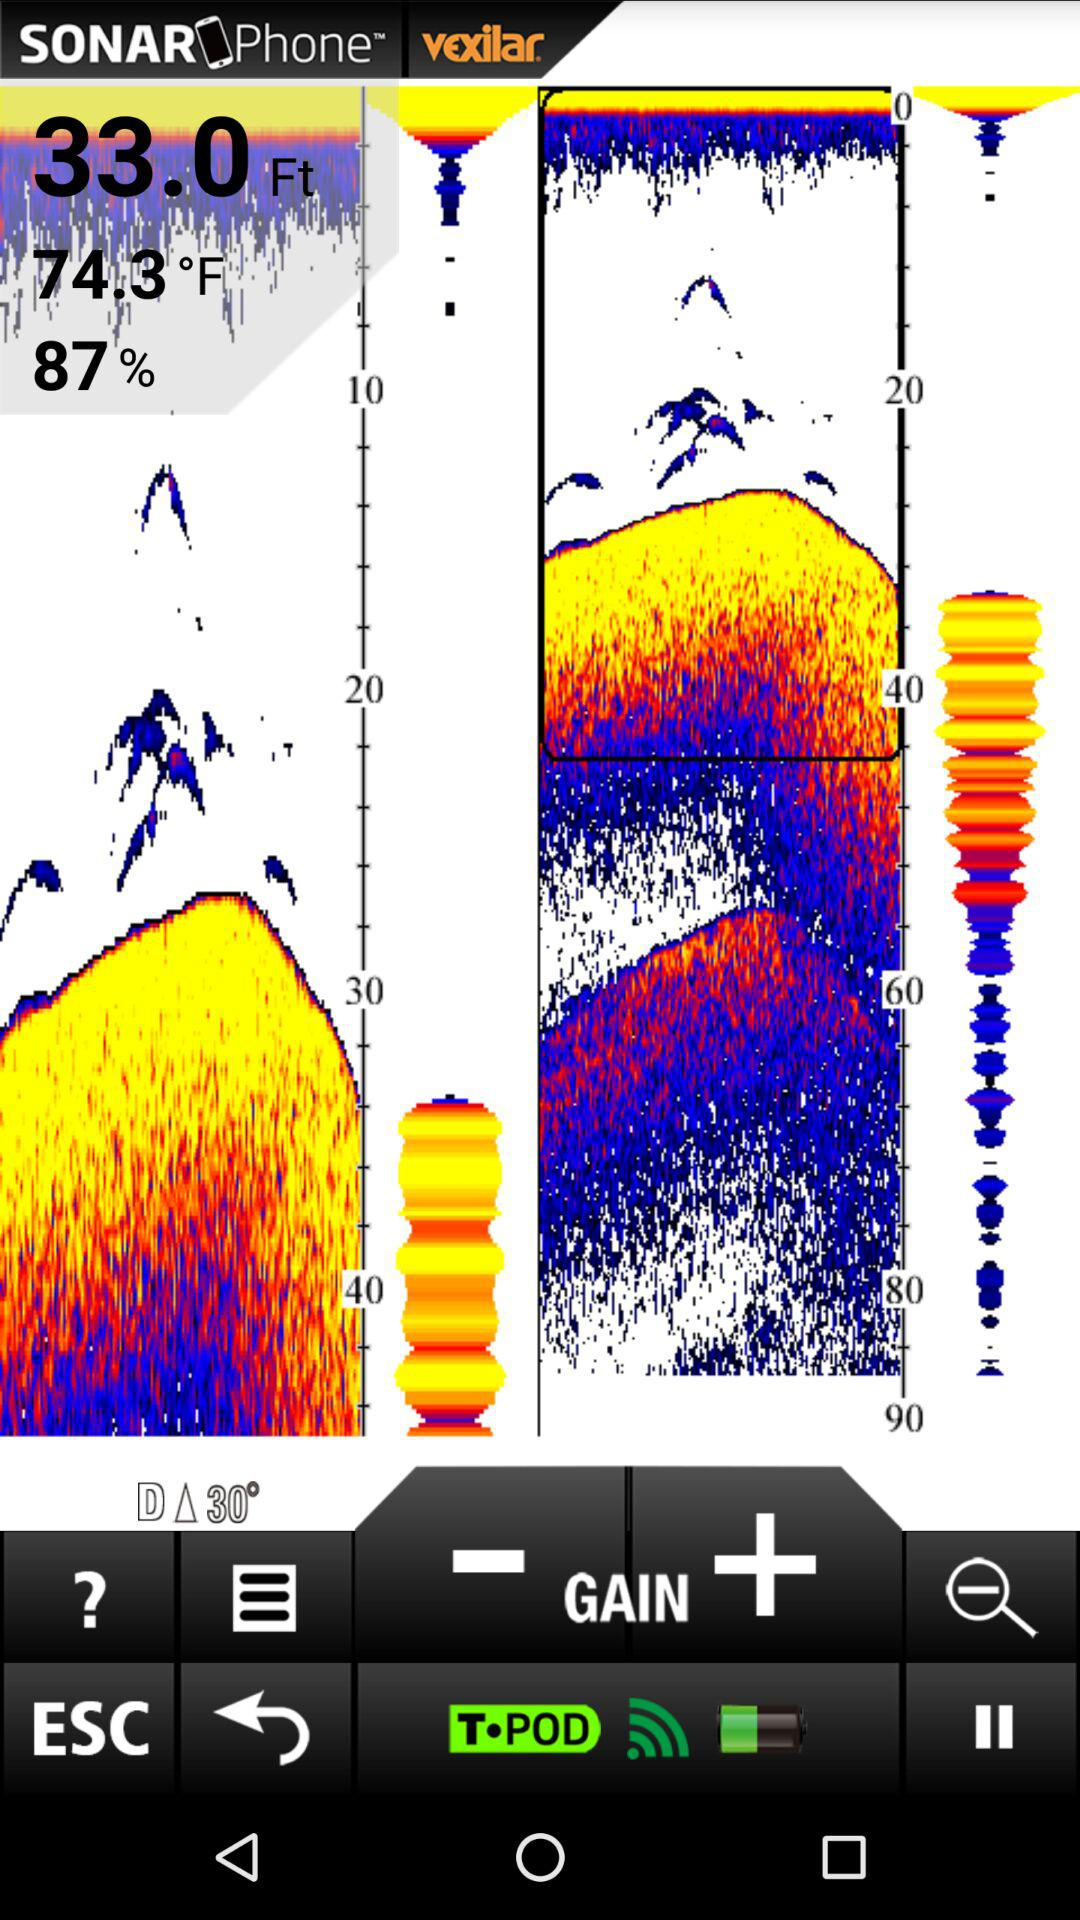What is the percentage shown here? The shown percentage is 87. 